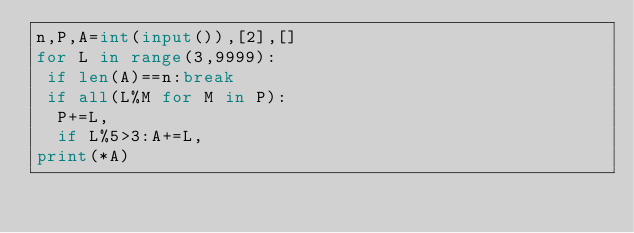Convert code to text. <code><loc_0><loc_0><loc_500><loc_500><_Python_>n,P,A=int(input()),[2],[]
for L in range(3,9999):
 if len(A)==n:break
 if all(L%M for M in P):
  P+=L,
  if L%5>3:A+=L,
print(*A)</code> 